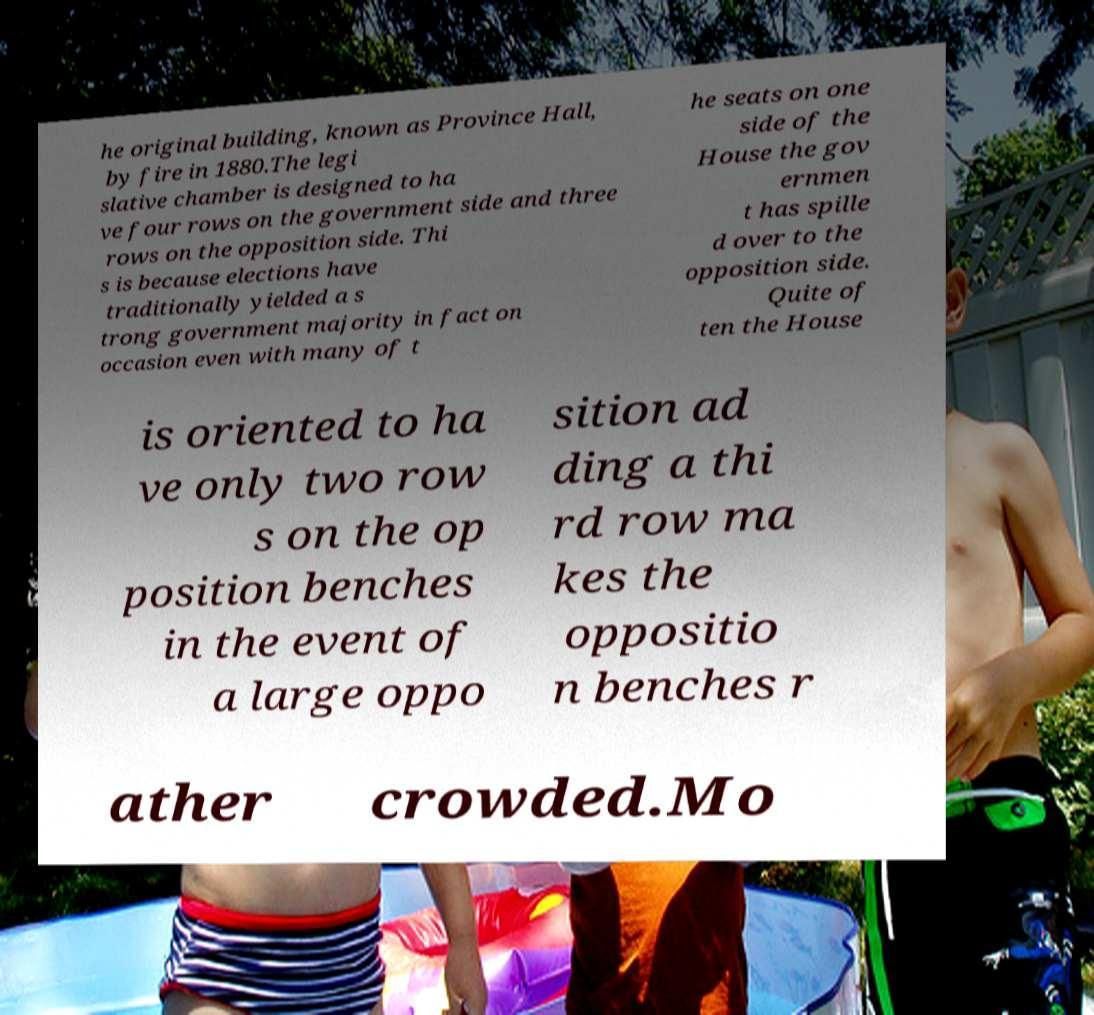I need the written content from this picture converted into text. Can you do that? he original building, known as Province Hall, by fire in 1880.The legi slative chamber is designed to ha ve four rows on the government side and three rows on the opposition side. Thi s is because elections have traditionally yielded a s trong government majority in fact on occasion even with many of t he seats on one side of the House the gov ernmen t has spille d over to the opposition side. Quite of ten the House is oriented to ha ve only two row s on the op position benches in the event of a large oppo sition ad ding a thi rd row ma kes the oppositio n benches r ather crowded.Mo 